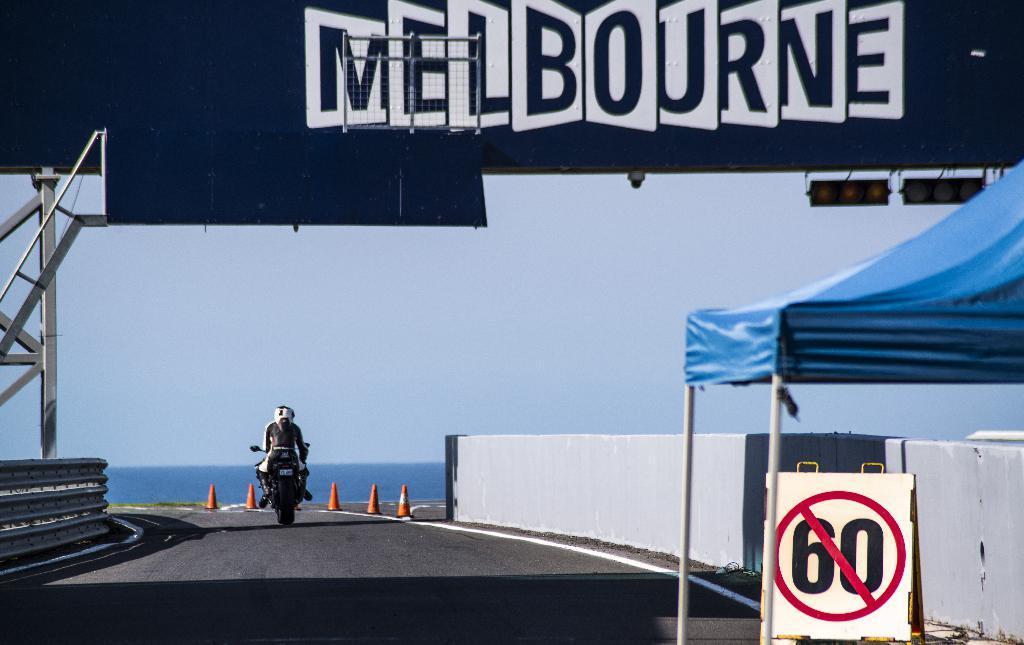Can you describe this image briefly? In the foreground of this image, on the right, there is a blue tent, sign board and a bridge wall. In the middle , there is a road and a bike moving on it and there are also traffic cones placed a side. On the left, there is a railing. On the top, there is a banner and lights. In the background, there is the sky and the water. 